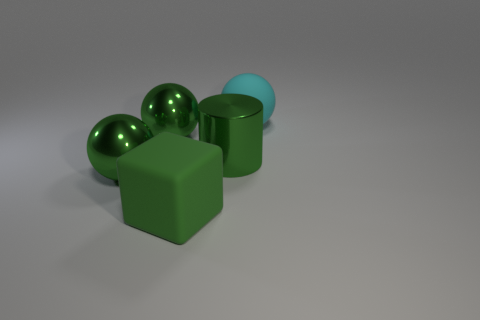Add 4 shiny spheres. How many objects exist? 9 Subtract all cylinders. How many objects are left? 4 Add 1 large green metal things. How many large green metal things are left? 4 Add 1 metal cylinders. How many metal cylinders exist? 2 Subtract 0 yellow cylinders. How many objects are left? 5 Subtract all big brown rubber blocks. Subtract all rubber cubes. How many objects are left? 4 